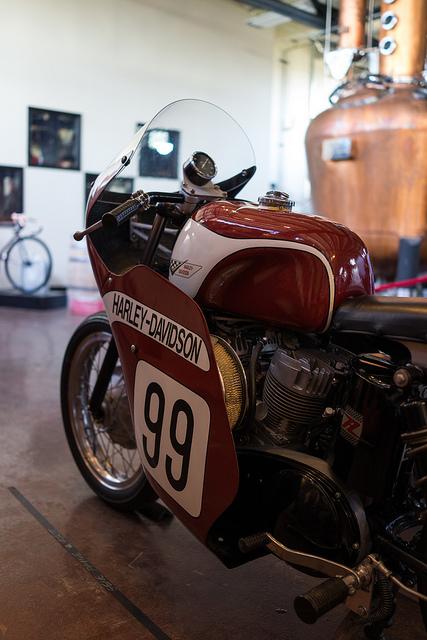What kind of vehicle is this?
Write a very short answer. Motorcycle. What country was the vehicle made in?
Be succinct. Usa. What number is on the motorcycle?
Quick response, please. 99. What is the brand of the motorcycle?
Be succinct. Harley davidson. What brand is shown?
Give a very brief answer. Harley davidson. 